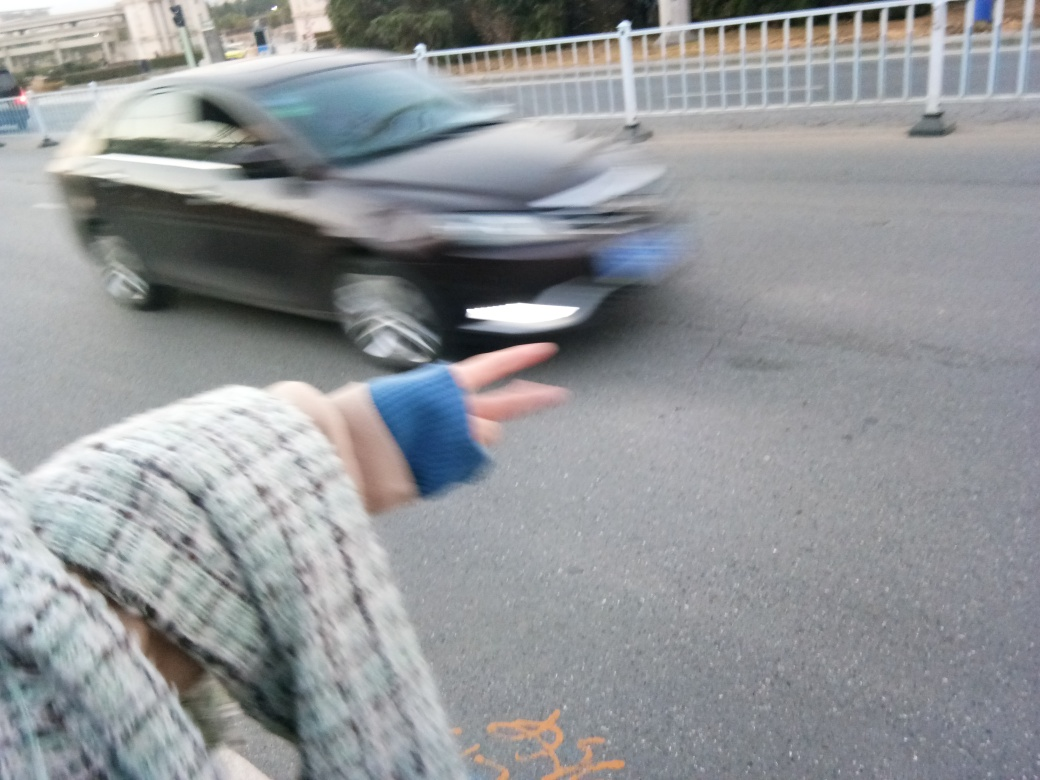What might the person be doing with their hand in this image? The outstretched hand with two fingers extended might be indicating a playful attempt at symbolically 'squishing' the moving car, a common playful gesture when aligning perspectives. Alternatively, it could also be a random hand gesture captured in the moment without a particular intention. 